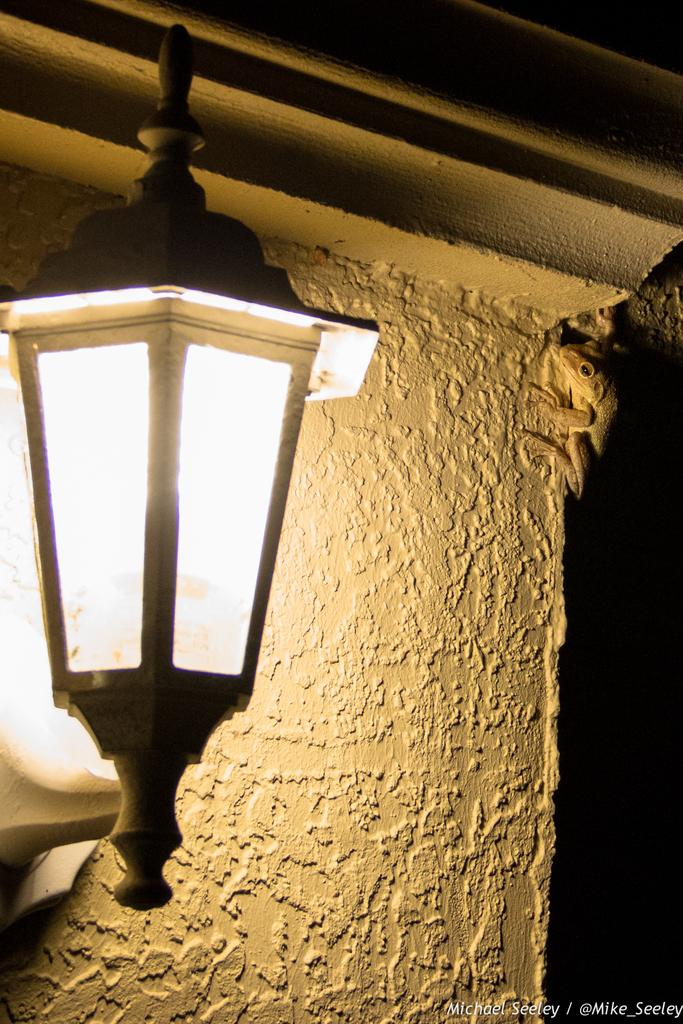What is located in the foreground of the image? There is a light in the foreground of the image. What can be seen in the background of the image? There is a wall in the background of the image. Are there any living creatures on the wall in the background? Yes, there is a lizard on the wall in the background. What type of pizzas are being served on the wall in the image? There are no pizzas present in the image; it features a lizard on a wall. What hobbies does the lizard on the wall enjoy in the image? There is no information about the lizard's hobbies in the image. 